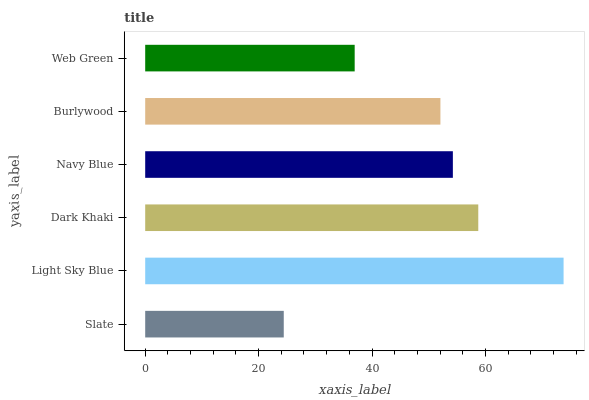Is Slate the minimum?
Answer yes or no. Yes. Is Light Sky Blue the maximum?
Answer yes or no. Yes. Is Dark Khaki the minimum?
Answer yes or no. No. Is Dark Khaki the maximum?
Answer yes or no. No. Is Light Sky Blue greater than Dark Khaki?
Answer yes or no. Yes. Is Dark Khaki less than Light Sky Blue?
Answer yes or no. Yes. Is Dark Khaki greater than Light Sky Blue?
Answer yes or no. No. Is Light Sky Blue less than Dark Khaki?
Answer yes or no. No. Is Navy Blue the high median?
Answer yes or no. Yes. Is Burlywood the low median?
Answer yes or no. Yes. Is Light Sky Blue the high median?
Answer yes or no. No. Is Slate the low median?
Answer yes or no. No. 